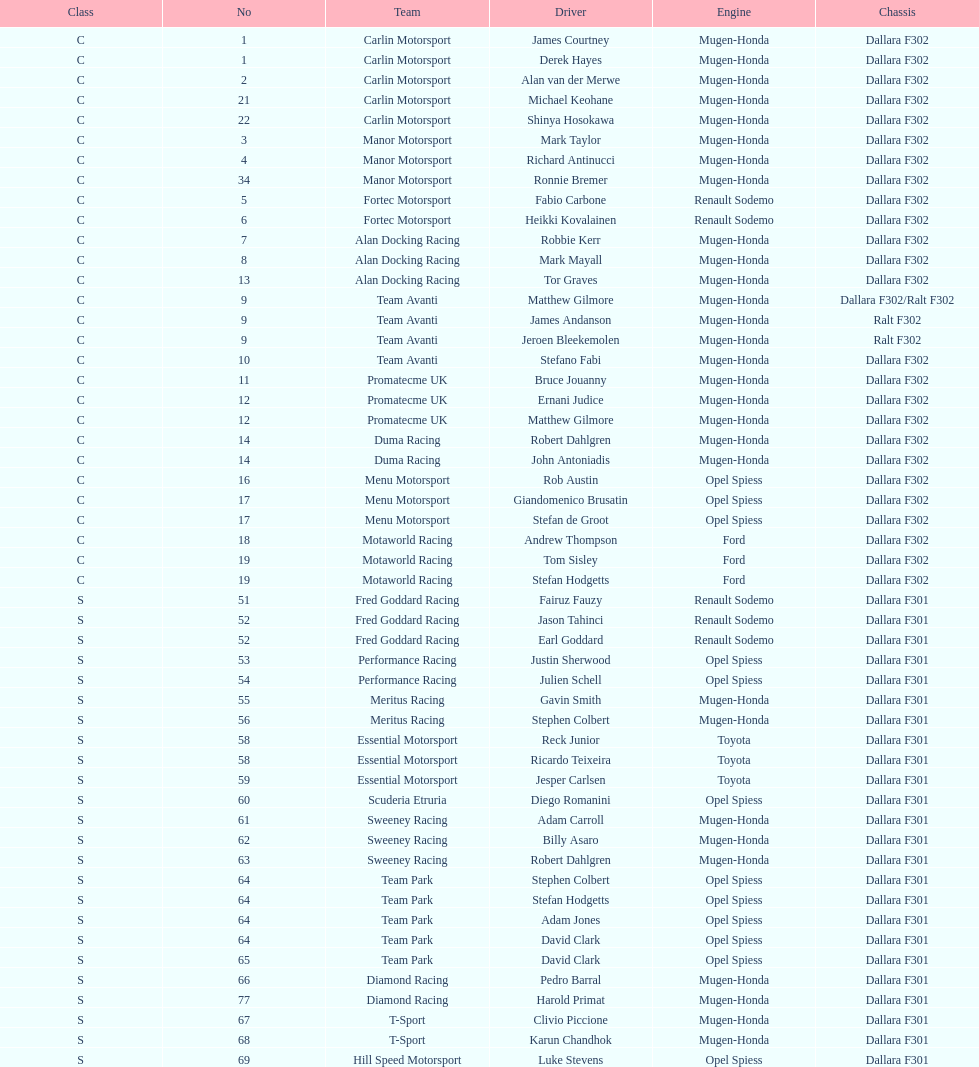How many teams had at least two drivers this season? 17. 